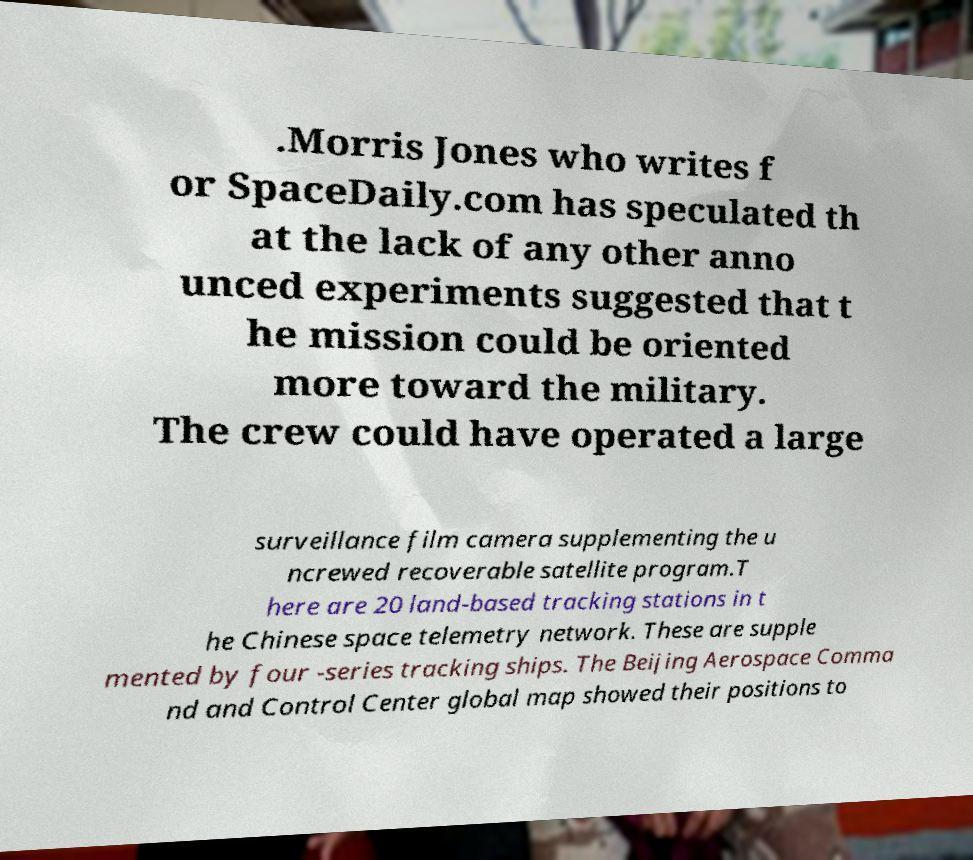Could you assist in decoding the text presented in this image and type it out clearly? .Morris Jones who writes f or SpaceDaily.com has speculated th at the lack of any other anno unced experiments suggested that t he mission could be oriented more toward the military. The crew could have operated a large surveillance film camera supplementing the u ncrewed recoverable satellite program.T here are 20 land-based tracking stations in t he Chinese space telemetry network. These are supple mented by four -series tracking ships. The Beijing Aerospace Comma nd and Control Center global map showed their positions to 